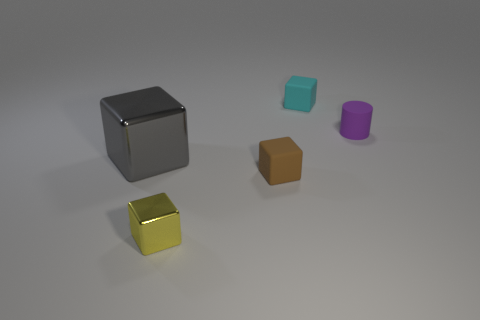Are there fewer rubber objects than small yellow shiny things?
Offer a terse response. No. Is the size of the yellow block the same as the object that is on the right side of the tiny cyan block?
Provide a short and direct response. Yes. There is a metal thing that is left of the metallic object that is in front of the big gray shiny thing; what is its color?
Offer a very short reply. Gray. What number of things are rubber objects to the right of the brown thing or small rubber objects that are in front of the cyan matte object?
Offer a terse response. 3. Do the gray metal cube and the matte cylinder have the same size?
Ensure brevity in your answer.  No. Is there anything else that is the same size as the yellow thing?
Your response must be concise. Yes. There is a tiny rubber object that is on the left side of the small cyan block; does it have the same shape as the tiny matte object that is behind the purple thing?
Make the answer very short. Yes. What is the size of the gray cube?
Provide a short and direct response. Large. What material is the block behind the thing on the right side of the tiny thing behind the tiny purple object?
Provide a short and direct response. Rubber. What number of other objects are there of the same color as the big shiny object?
Offer a very short reply. 0. 